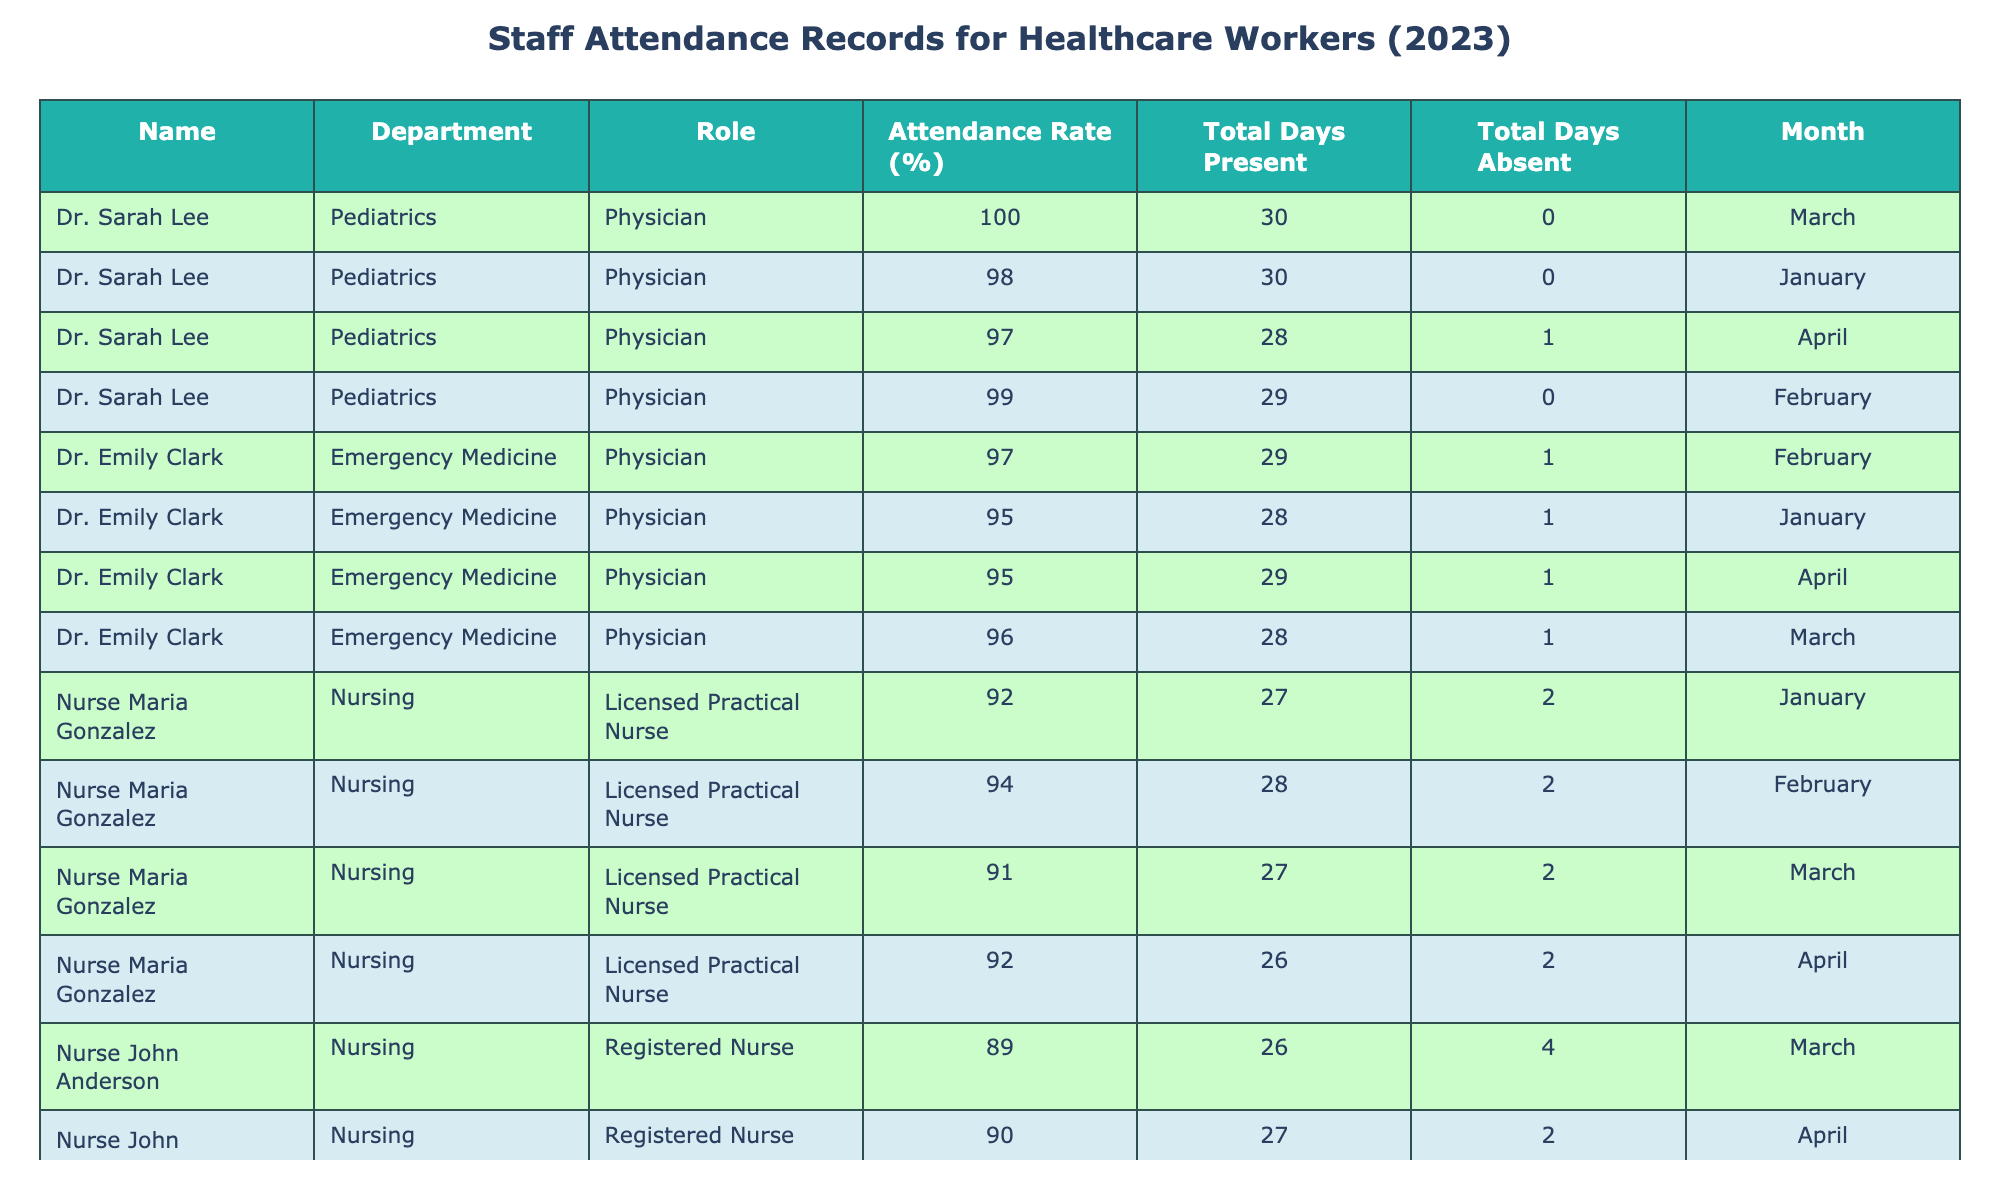What is the attendance rate of Dr. Sarah Lee in March? In the table, locate Dr. Sarah Lee under the March row, and find the value in the Attendance Rate (%) column, which is 100% for March.
Answer: 100% Which nurse had the lowest attendance rate over the four months? To find this, check the attendance rates for nurses across all months, identifying Nurse John Anderson with the lowest average rate of 89% computed from (90 + 88 + 89 + 90)/4.
Answer: Nurse John Anderson How many total days was Nurse Maria Gonzalez absent in January? Look for Nurse Maria Gonzalez in the January row, where the Total Days Absent value is recorded as 2.
Answer: 2 What is the average attendance rate for Dr. Emily Clark across the four months? Calculate the average by summing her attendance rates for the four months (95 + 97 + 96 + 95) = 383 and then dividing by 4, yielding an average attendance rate of 95.75%.
Answer: 95.75% Did Dr. Michael Brown take any leave in February? Check February's row for Dr. Michael Brown, and see that Total Leave Days is recorded as 1, which confirms he did take leave.
Answer: Yes Who has the highest total presence days in January? Review the Total Days Present column for January, where Dr. Sarah Lee has the highest presence at 30 days.
Answer: Dr. Sarah Lee How many days were Nurse Maria Gonzalez absent in total across January and February? Find Nurse Maria Gonzalez's Total Days Absent for January (2) and February (2), summing these values gives 4 total days absent.
Answer: 4 What is the difference in attendance rate between Dr. Michael Brown in January and March? Check Dr. Michael Brown's attendance rates: January (85%) and March (83%). The difference is 85 - 83 = 2%.
Answer: 2% How many total leave days did Dr. Emily Clark take throughout 2023? Summing the Total Leave Days for Dr. Emily Clark in each month (1 + 0 + 1 + 0) results in a total of 2 leave days in 2023.
Answer: 2 Which staff member recorded the highest attendance rate? By reviewing the Attendance Rate (%) column, Dr. Sarah Lee recorded the highest attendance rate at 100%.
Answer: Dr. Sarah Lee 